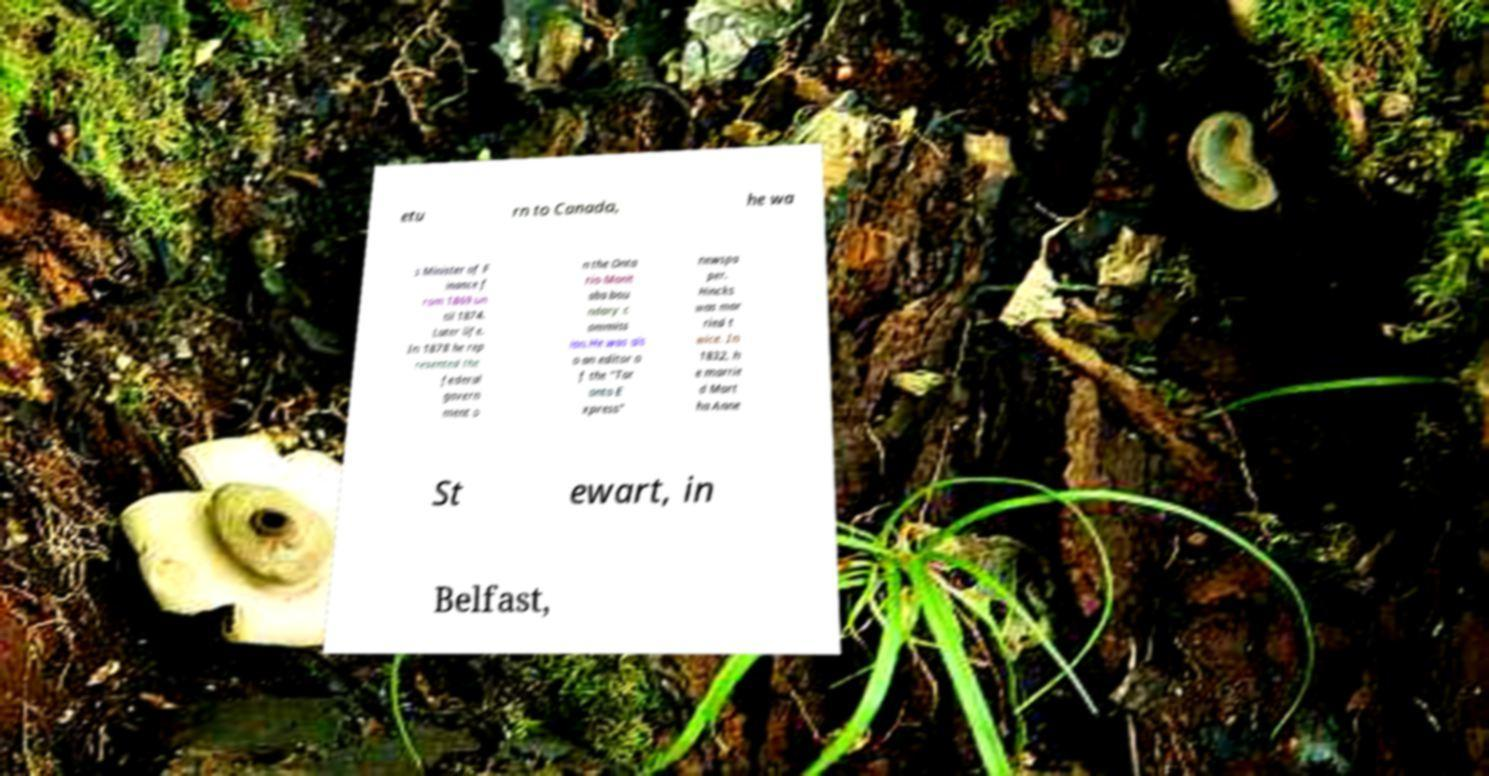Please read and relay the text visible in this image. What does it say? etu rn to Canada, he wa s Minister of F inance f rom 1869 un til 1874. Later life. In 1878 he rep resented the federal govern ment o n the Onta rio-Manit oba bou ndary c ommiss ion.He was als o an editor o f the "Tor onto E xpress" newspa per. Hincks was mar ried t wice. In 1832, h e marrie d Mart ha Anne St ewart, in Belfast, 